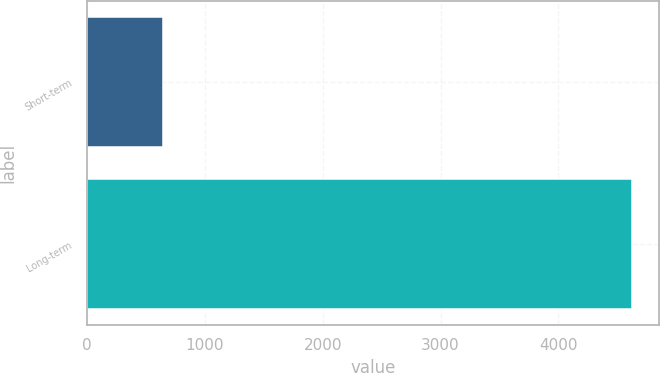Convert chart to OTSL. <chart><loc_0><loc_0><loc_500><loc_500><bar_chart><fcel>Short-term<fcel>Long-term<nl><fcel>648<fcel>4624<nl></chart> 